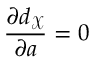<formula> <loc_0><loc_0><loc_500><loc_500>\frac { \partial d _ { \mathcal { X } } } { \partial a } = 0</formula> 